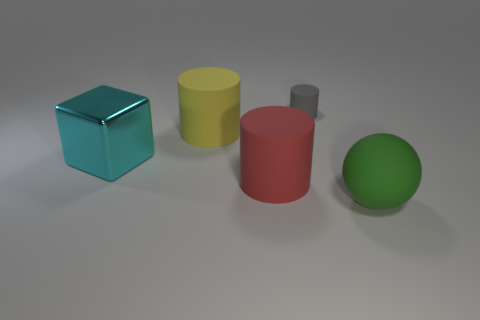What material is the small gray object that is the same shape as the big red object?
Ensure brevity in your answer.  Rubber. There is a thing that is to the right of the tiny gray rubber cylinder; how many gray matte objects are in front of it?
Your answer should be very brief. 0. There is a cylinder that is in front of the cylinder left of the cylinder in front of the cyan shiny cube; how big is it?
Keep it short and to the point. Large. What is the color of the big object to the right of the big cylinder on the right side of the big yellow object?
Your response must be concise. Green. How many other things are there of the same material as the large green sphere?
Provide a short and direct response. 3. How many other objects are the same color as the metal cube?
Make the answer very short. 0. What material is the large object that is right of the cylinder that is right of the big red object?
Your response must be concise. Rubber. Are there any shiny objects?
Provide a succinct answer. Yes. There is a cylinder that is in front of the large matte thing behind the big red cylinder; what size is it?
Offer a terse response. Large. Is the number of large yellow cylinders behind the big green sphere greater than the number of metal blocks that are to the right of the yellow object?
Ensure brevity in your answer.  Yes. 